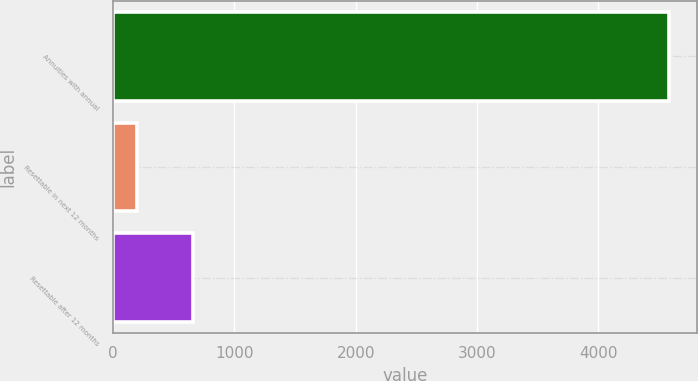Convert chart. <chart><loc_0><loc_0><loc_500><loc_500><bar_chart><fcel>Annuities with annual<fcel>Resettable in next 12 months<fcel>Resettable after 12 months<nl><fcel>4585<fcel>198<fcel>660<nl></chart> 